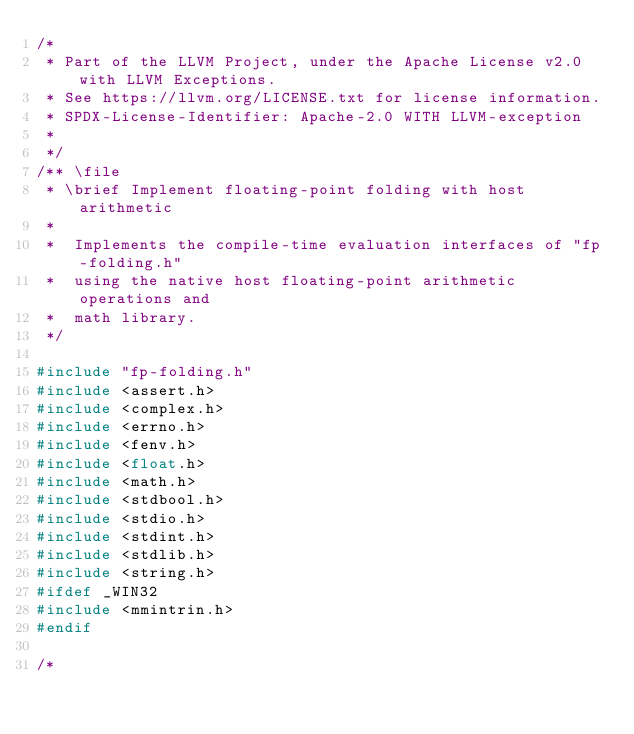Convert code to text. <code><loc_0><loc_0><loc_500><loc_500><_C_>/*
 * Part of the LLVM Project, under the Apache License v2.0 with LLVM Exceptions.
 * See https://llvm.org/LICENSE.txt for license information.
 * SPDX-License-Identifier: Apache-2.0 WITH LLVM-exception
 *
 */
/** \file
 * \brief Implement floating-point folding with host arithmetic
 *
 *  Implements the compile-time evaluation interfaces of "fp-folding.h"
 *  using the native host floating-point arithmetic operations and
 *  math library.
 */

#include "fp-folding.h"
#include <assert.h>
#include <complex.h>
#include <errno.h>
#include <fenv.h>
#include <float.h>
#include <math.h>
#include <stdbool.h>
#include <stdio.h>
#include <stdint.h>
#include <stdlib.h>
#include <string.h>
#ifdef _WIN32
#include <mmintrin.h>
#endif

/*</code> 